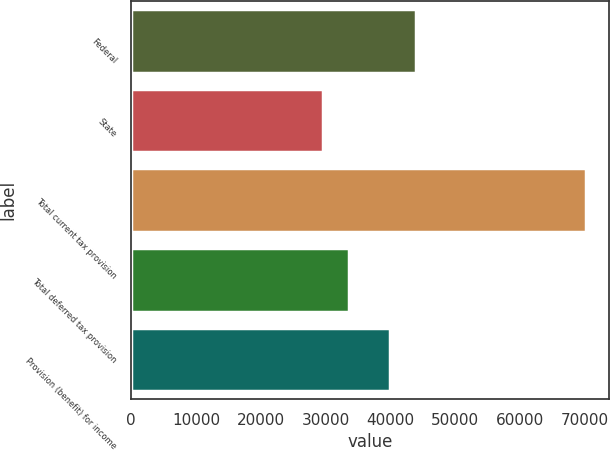Convert chart. <chart><loc_0><loc_0><loc_500><loc_500><bar_chart><fcel>Federal<fcel>State<fcel>Total current tax provision<fcel>Total deferred tax provision<fcel>Provision (benefit) for income<nl><fcel>44031.5<fcel>29539<fcel>70214<fcel>33606.5<fcel>39964<nl></chart> 